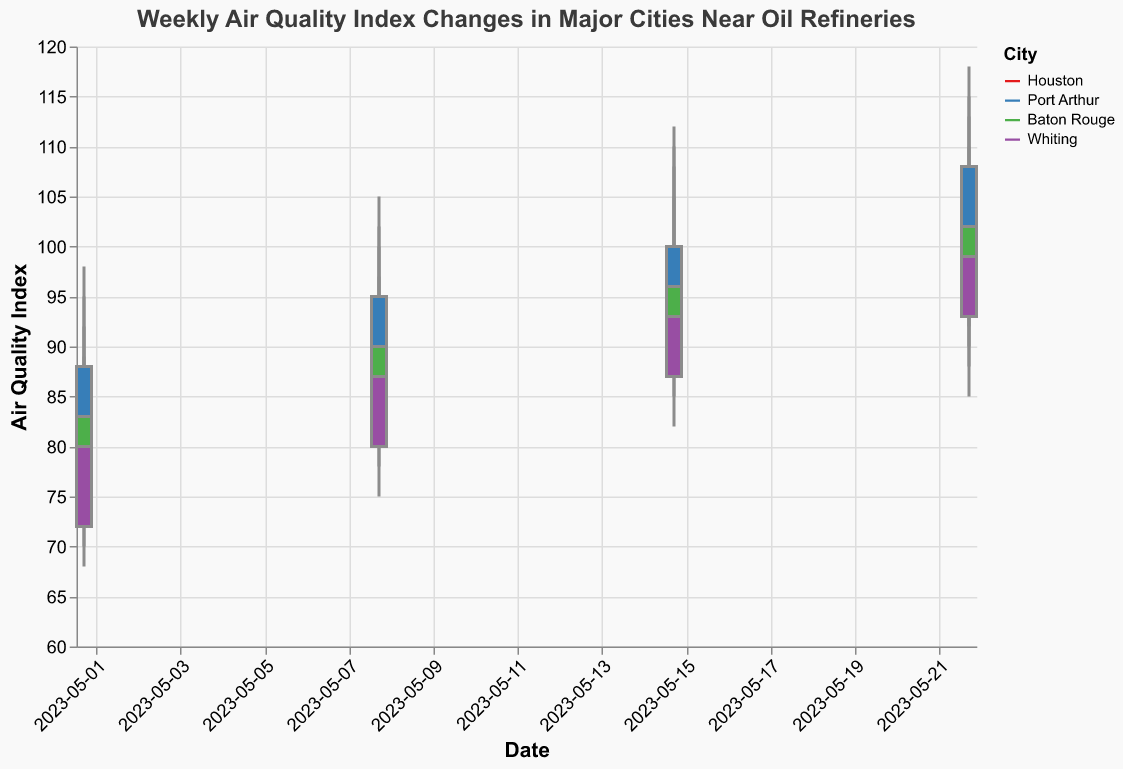Which city had the highest Air Quality Index (AQI) on the week of May 22, 2023? Look at the 'High' value for each city on 2023-05-22. Houston had the highest AQI with a value of 115.
Answer: Houston How did the AQI change in Baton Rouge from May 1 to May 22, 2023? Compare the 'Open' value of May 1 to the 'Close' value of May 22 in Baton Rouge. It increased from 75 to 102.
Answer: Increased by 27 What was the largest single-week increase in the 'Close' value for any city? Examine the 'Close' values week by week for all cities. The largest increase is in Port Arthur from May 1 (88) to May 8 (95), which is an increase of 7.
Answer: Port Arthur with an increase of 7 Which city had the most stable AQI in terms of 'Low' readings from May 1 to May 22? Examine the 'Low' values for each city over the four weeks. Houston had 'Low' values of 72, 80, 88, and 90, which shows more variation compared to others. Whiting had the 'Low' values of 68, 75, 82, 85, which shows less variation compared to Baton Rouge and Port Arthur.
Answer: Whiting On which date did all cities record their highest AQI 'High' values for the month? Compare the 'High' values across all dates for each city. The date when all cities recorded their highest values was on May 22, with 'High' values as follows: Houston (115), Port Arthur (118), Baton Rouge (113), Whiting (110).
Answer: May 22, 2023 What is the average highest AQI recorded in Houston over the four weeks? Sum the 'High' values for Houston: 95 + 102 + 110 + 115 = 422. Divide by 4 to get the average, 422/4 = 105.5.
Answer: 105.5 What was the AQI range (difference between 'High' and 'Low') for Port Arthur on May 15, 2023? Subtract the 'Low' value from the 'High' value for Port Arthur on May 15: 112 - 90 = 22.
Answer: 22 Which city showed the most improvement (decrease) in AQI from Open to Close on May 22, 2023? Compare the 'Open' and 'Close' values for each city on 2023-05-22. Baton Rouge showed the most improvement from 96 (Open) to 102 (Close), a decrease of 6.
Answer: Baton Rouge Which city's AQI showed a consistent increase each week? Track the 'Close' values for each city across the weeks. Houston's AQI consistently increases from 85, 93, 98 to 105.
Answer: Houston 